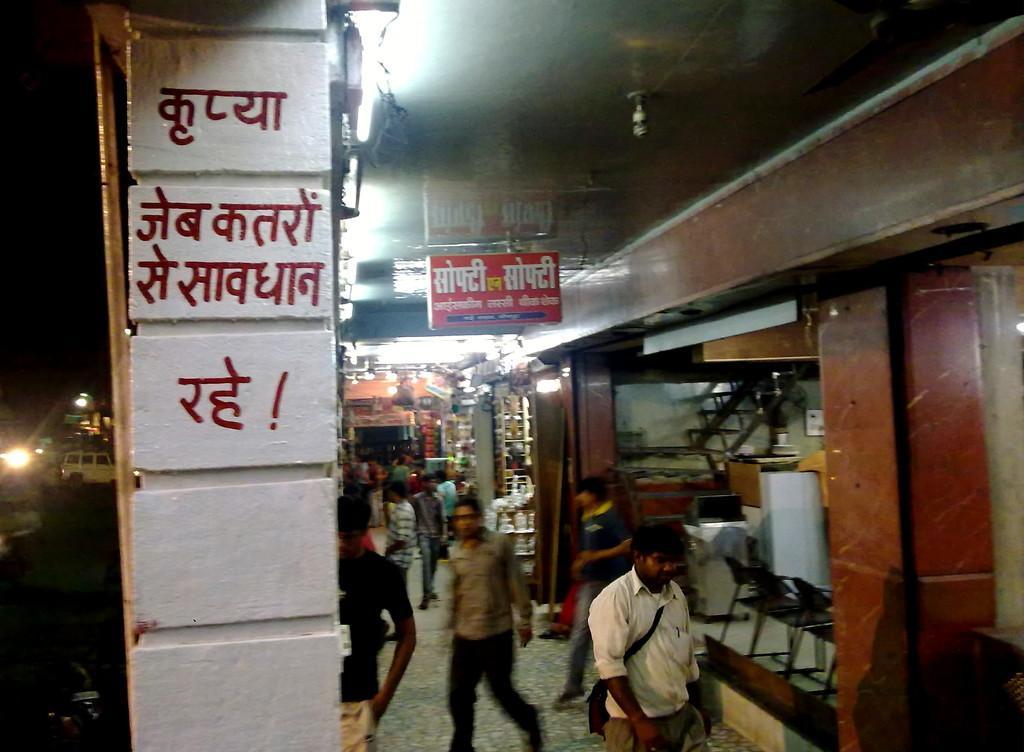Describe this image in one or two sentences. The picture is taken in a building. On the right there is a shop, in the shop there are chairs and other objects. In the center of the picture there are people walking. At the top there are lights and a banner. On the left there is a pillar. In the background towards left there are vehicles and lights. In the center of the background there are shops. In the shops there are various objects. 